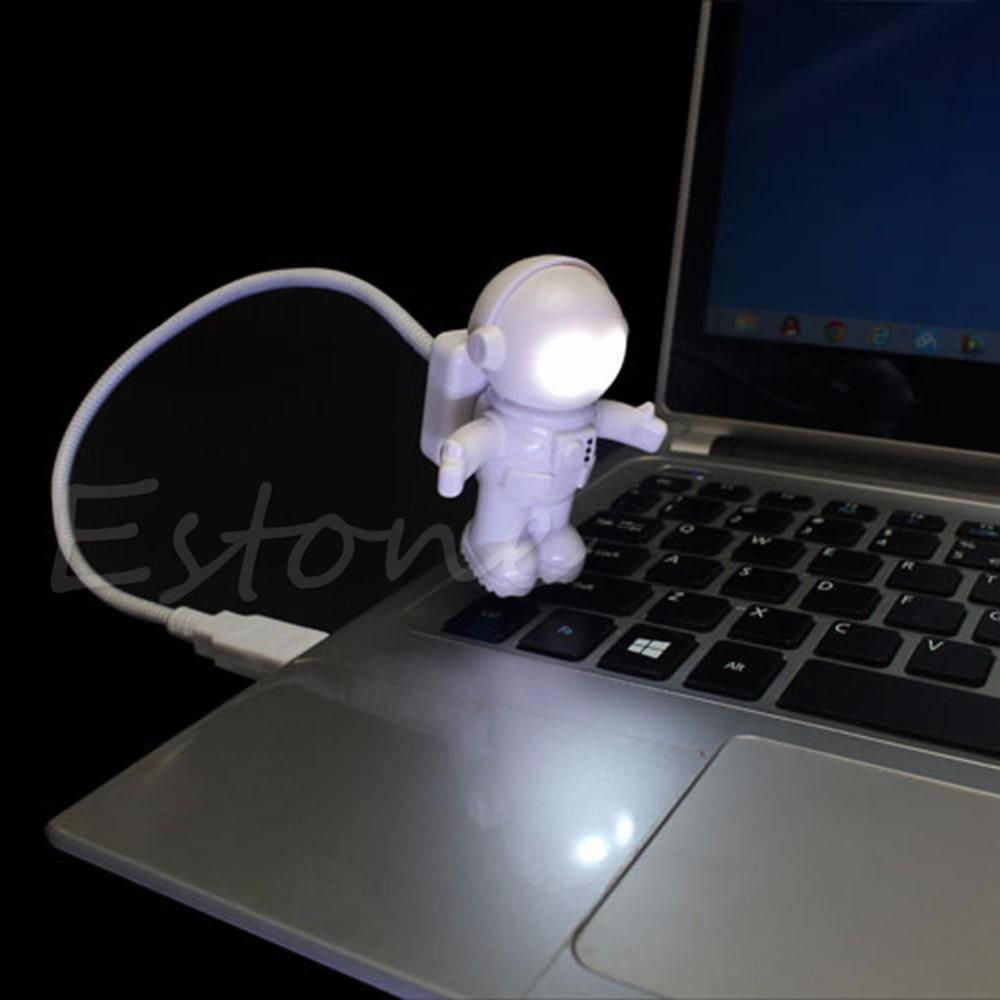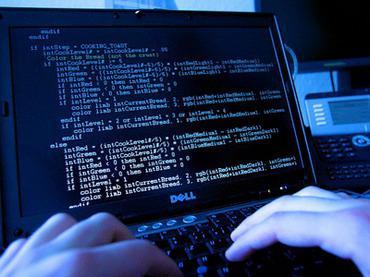The first image is the image on the left, the second image is the image on the right. For the images shown, is this caption "In 1 of the images, 2 hands are typing." true? Answer yes or no. Yes. The first image is the image on the left, the second image is the image on the right. Assess this claim about the two images: "A light source is attached to a laptop". Correct or not? Answer yes or no. Yes. 